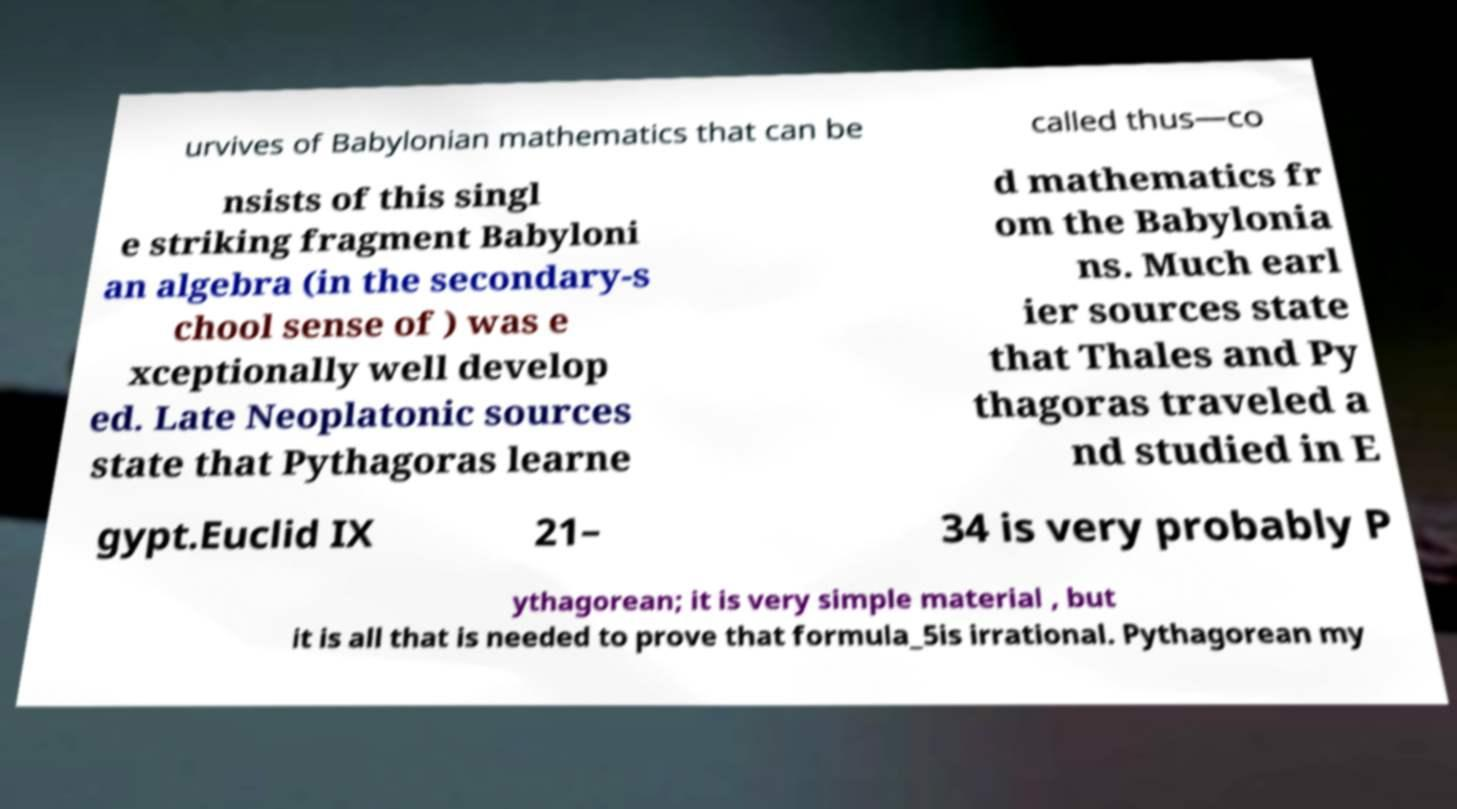I need the written content from this picture converted into text. Can you do that? urvives of Babylonian mathematics that can be called thus—co nsists of this singl e striking fragment Babyloni an algebra (in the secondary-s chool sense of ) was e xceptionally well develop ed. Late Neoplatonic sources state that Pythagoras learne d mathematics fr om the Babylonia ns. Much earl ier sources state that Thales and Py thagoras traveled a nd studied in E gypt.Euclid IX 21– 34 is very probably P ythagorean; it is very simple material , but it is all that is needed to prove that formula_5is irrational. Pythagorean my 